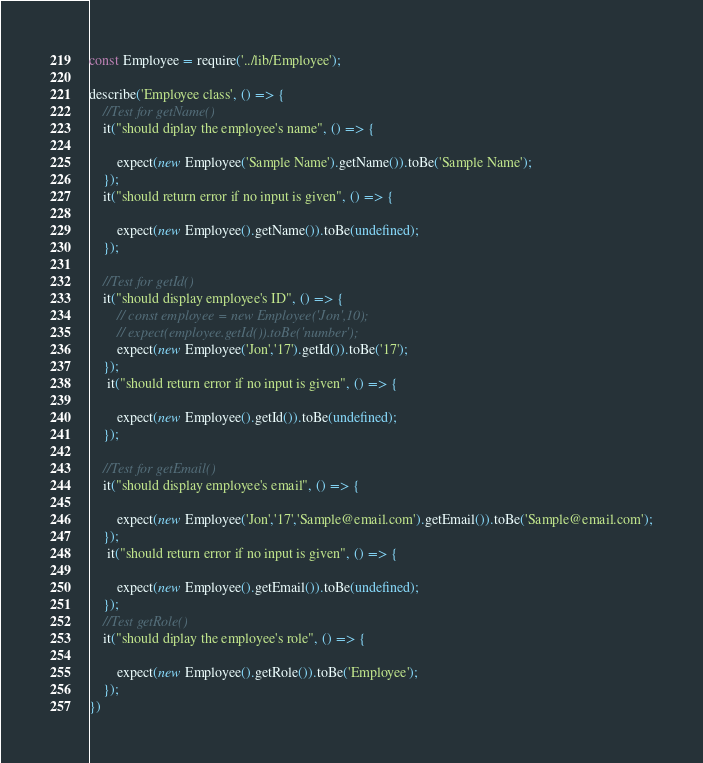<code> <loc_0><loc_0><loc_500><loc_500><_JavaScript_>const Employee = require('../lib/Employee');

describe('Employee class', () => {
    //Test for getName()
    it("should diplay the employee's name", () => {

        expect(new Employee('Sample Name').getName()).toBe('Sample Name');
    });
    it("should return error if no input is given", () => {

        expect(new Employee().getName()).toBe(undefined);
    });

    //Test for getId()
    it("should display employee's ID", () => {
        // const employee = new Employee('Jon',10);
        // expect(employee.getId()).toBe('number');
        expect(new Employee('Jon','17').getId()).toBe('17');
    });
     it("should return error if no input is given", () => {

        expect(new Employee().getId()).toBe(undefined);
    });

    //Test for getEmail()
    it("should display employee's email", () => {

        expect(new Employee('Jon','17','Sample@email.com').getEmail()).toBe('Sample@email.com');
    });
     it("should return error if no input is given", () => {

        expect(new Employee().getEmail()).toBe(undefined);
    });
    //Test getRole()
    it("should diplay the employee's role", () => {

        expect(new Employee().getRole()).toBe('Employee');
    });
})</code> 